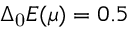Convert formula to latex. <formula><loc_0><loc_0><loc_500><loc_500>\Delta _ { 0 } E ( \mu ) = 0 . 5</formula> 